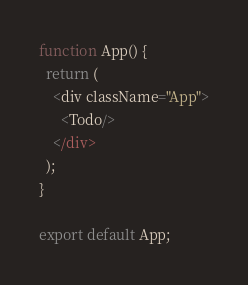Convert code to text. <code><loc_0><loc_0><loc_500><loc_500><_JavaScript_>function App() {
  return (
    <div className="App">
      <Todo/>
    </div>
  );
}

export default App;
</code> 